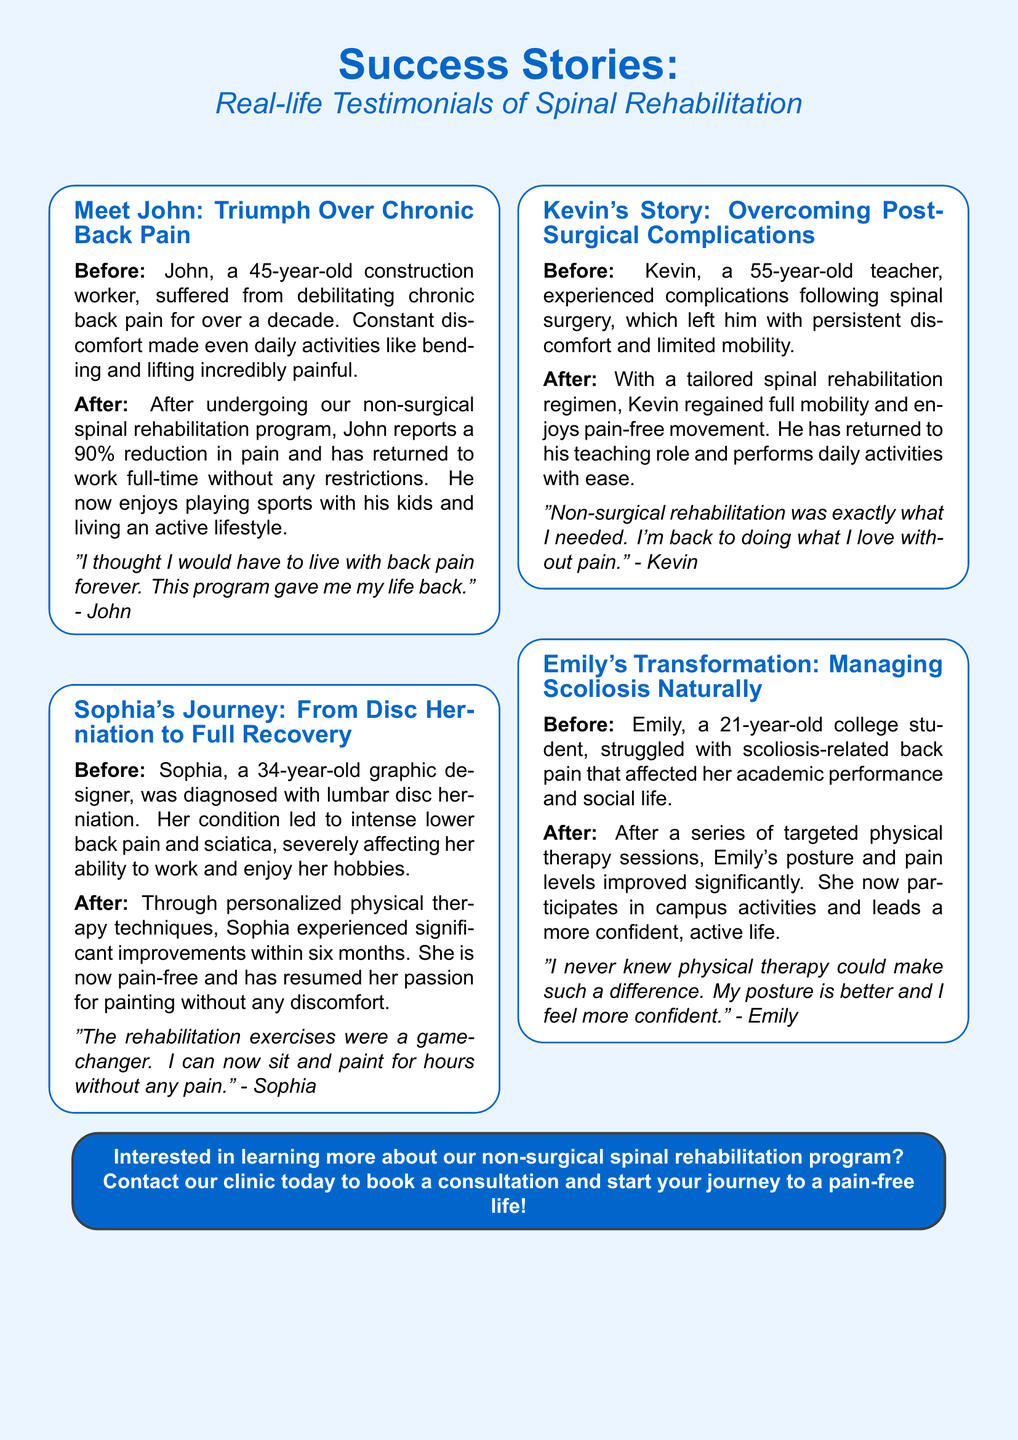What is the title of the flyer? The title of the flyer is prominently displayed at the top, showcasing the main theme of success stories and testimonials.
Answer: Success Stories: Real-life Testimonials of Spinal Rehabilitation How many testimonials are presented in the document? The document includes a section for each of four individuals who share their stories, indicating there are four testimonials.
Answer: Four What was John's profession before his rehabilitation? The document describes John's background in detail, noting his job and its relevance to his condition.
Answer: Construction worker What percentage reduction in pain did John report after rehabilitation? The document specifies the extent of John's improvement following the program, providing a clear percentage.
Answer: 90% How long did it take for Sophia to experience significant improvements? The document notes the time frame in which Sophia saw substantial changes, indicating her progress duration.
Answer: Six months What condition did Sophia suffer from? The testimonial details explicitly mention the diagnosis Sophia received leading to her symptoms.
Answer: Lumbar disc herniation Which patient's story involves complications following surgery? The document explicitly indicates Kevin's situation, describing the aftermath of his surgical experience.
Answer: Kevin's Story What activity did Emily regain the confidence to participate in after therapy? The document highlights Emily's improved ability to engage in social aspects of her life post-treatment.
Answer: Campus activities What type of rehabilitation program is being offered? The document summarizes the nature of the treatment provided, which is the central focus of the testimonials.
Answer: Non-surgical spinal rehabilitation program 